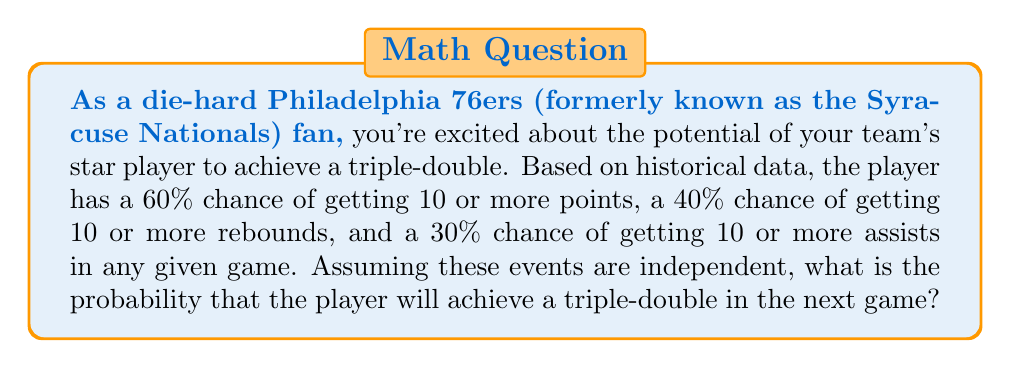Provide a solution to this math problem. To solve this problem, we need to understand the concept of independent events and how to calculate their joint probability.

1. Define the events:
   Let A = event of scoring 10 or more points
   Let B = event of getting 10 or more rebounds
   Let C = event of getting 10 or more assists

2. Given probabilities:
   P(A) = 60% = 0.60
   P(B) = 40% = 0.40
   P(C) = 30% = 0.30

3. Since the events are independent, the probability of all three events occurring simultaneously is the product of their individual probabilities:

   $$P(\text{Triple-Double}) = P(A \cap B \cap C) = P(A) \times P(B) \times P(C)$$

4. Substitute the values:

   $$P(\text{Triple-Double}) = 0.60 \times 0.40 \times 0.30$$

5. Calculate:

   $$P(\text{Triple-Double}) = 0.072 = 7.2\%$$

Therefore, the probability of the player achieving a triple-double in the next game is 7.2%.
Answer: $0.072$ or $7.2\%$ 